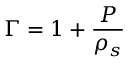Convert formula to latex. <formula><loc_0><loc_0><loc_500><loc_500>\Gamma = 1 + \frac { P } \rho _ { s } }</formula> 